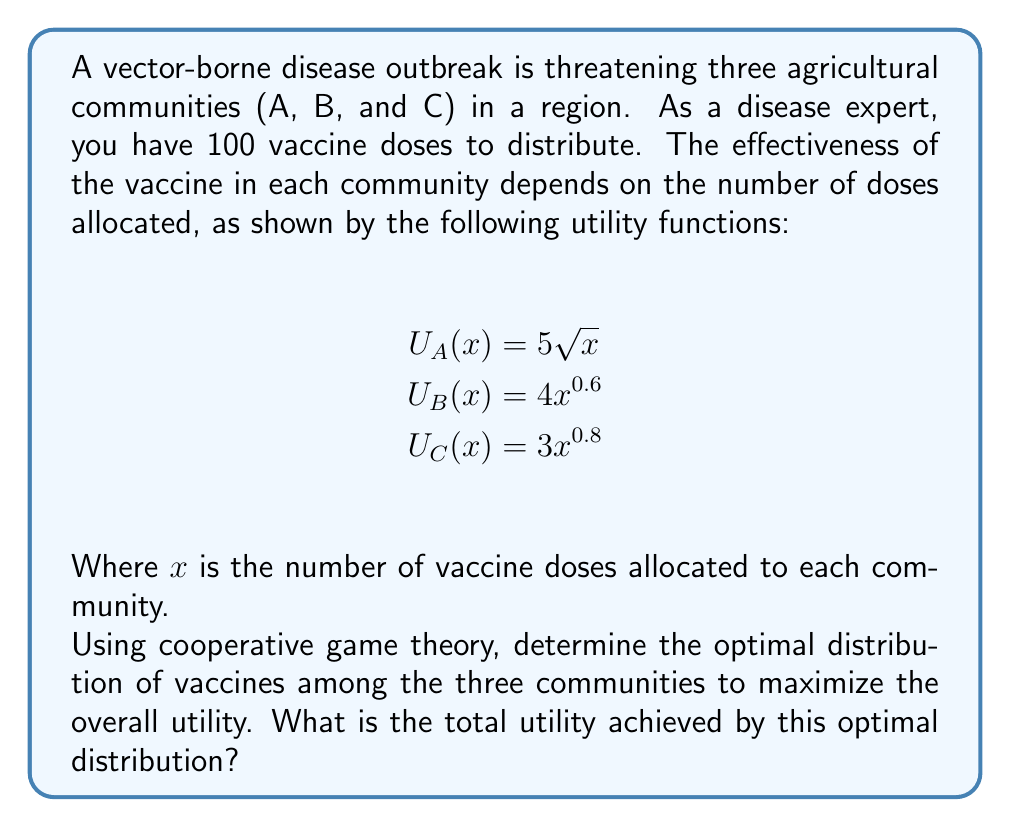Show me your answer to this math problem. To solve this problem, we'll use the concept of marginal contributions from cooperative game theory. We'll follow these steps:

1) First, we need to find the optimal distribution of vaccines. This occurs when the marginal utility of each community is equal.

2) The marginal utility for each community is the derivative of its utility function:

   $U'_A(x) = \frac{5}{2\sqrt{x}}$
   $U'_B(x) = 2.4x^{-0.4}$
   $U'_C(x) = 2.4x^{-0.2}$

3) Let the optimal allocations be $x_A$, $x_B$, and $x_C$. At the optimal point:

   $\frac{5}{2\sqrt{x_A}} = 2.4x_B^{-0.4} = 2.4x_C^{-0.2}$

4) We also know that $x_A + x_B + x_C = 100$ (all vaccines must be used)

5) From the equality of marginal utilities, we can derive:

   $x_B = (\frac{5}{4.8\sqrt{x_A}})^{2.5}$ and $x_C = (\frac{5}{4.8\sqrt{x_A}})^5$

6) Substituting these into the total vaccine constraint:

   $x_A + (\frac{5}{4.8\sqrt{x_A}})^{2.5} + (\frac{5}{4.8\sqrt{x_A}})^5 = 100$

7) This equation can be solved numerically to get $x_A \approx 44.4$

8) Then, $x_B \approx 32.8$ and $x_C \approx 22.8$

9) Now we can calculate the total utility:

   $U_{total} = 5\sqrt{44.4} + 4(32.8)^{0.6} + 3(22.8)^{0.8}$

10) Calculating this gives us the total utility.
Answer: The optimal distribution is approximately 44.4 doses to community A, 32.8 doses to community B, and 22.8 doses to community C. The total utility achieved by this distribution is approximately 71.3 units. 